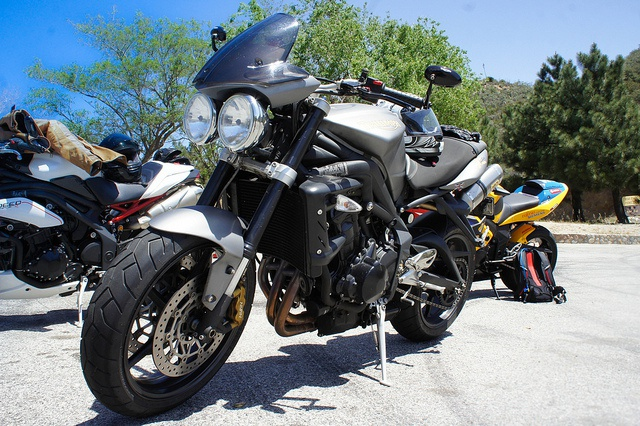Describe the objects in this image and their specific colors. I can see motorcycle in gray, black, lightgray, and darkgray tones, motorcycle in gray, black, white, and darkgray tones, motorcycle in gray, black, lightgray, and orange tones, and backpack in gray, black, navy, and maroon tones in this image. 